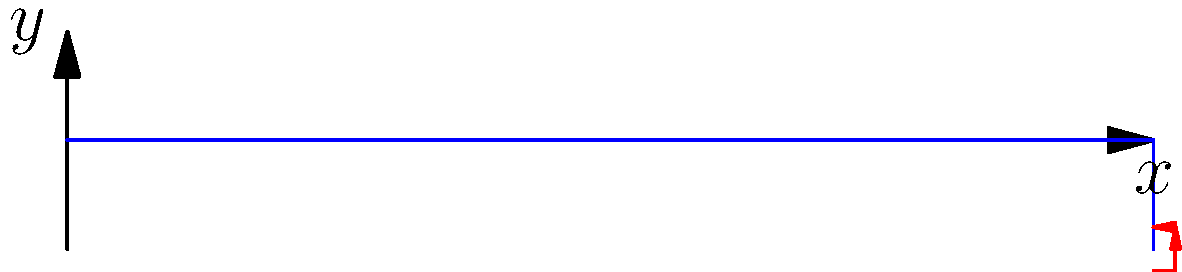Consider a cantilever beam of length $L$ with a point load $P$ applied at its free end. The beam has a Young's modulus $E$ and moment of inertia $I$. Derive an expression for the maximum normal stress $\sigma_{max}$ in the beam as a function of $x$, where $x$ is the distance from the fixed end. To find the maximum normal stress in the cantilever beam, we'll follow these steps:

1) The bending moment $M(x)$ at any point $x$ along the beam is:
   $$M(x) = P(L-x)$$

2) The normal stress $\sigma$ at any point in the beam's cross-section is given by:
   $$\sigma = \frac{My}{I}$$
   where $y$ is the distance from the neutral axis.

3) The maximum stress occurs at the outer fibers of the beam, where $y$ is maximum. Let's call this maximum distance from the neutral axis $c$. Then:
   $$\sigma_{max} = \frac{Mc}{I}$$

4) Substituting the expression for $M(x)$:
   $$\sigma_{max}(x) = \frac{P(L-x)c}{I}$$

5) This expression gives the maximum normal stress at any point $x$ along the beam's length.

6) The absolute maximum stress will occur at the fixed end where $x=0$:
   $$\sigma_{max}(0) = \frac{PLc}{I}$$

Thus, the maximum normal stress varies linearly along the length of the beam, reaching its peak at the fixed end and reducing to zero at the free end.
Answer: $\sigma_{max}(x) = \frac{P(L-x)c}{I}$ 